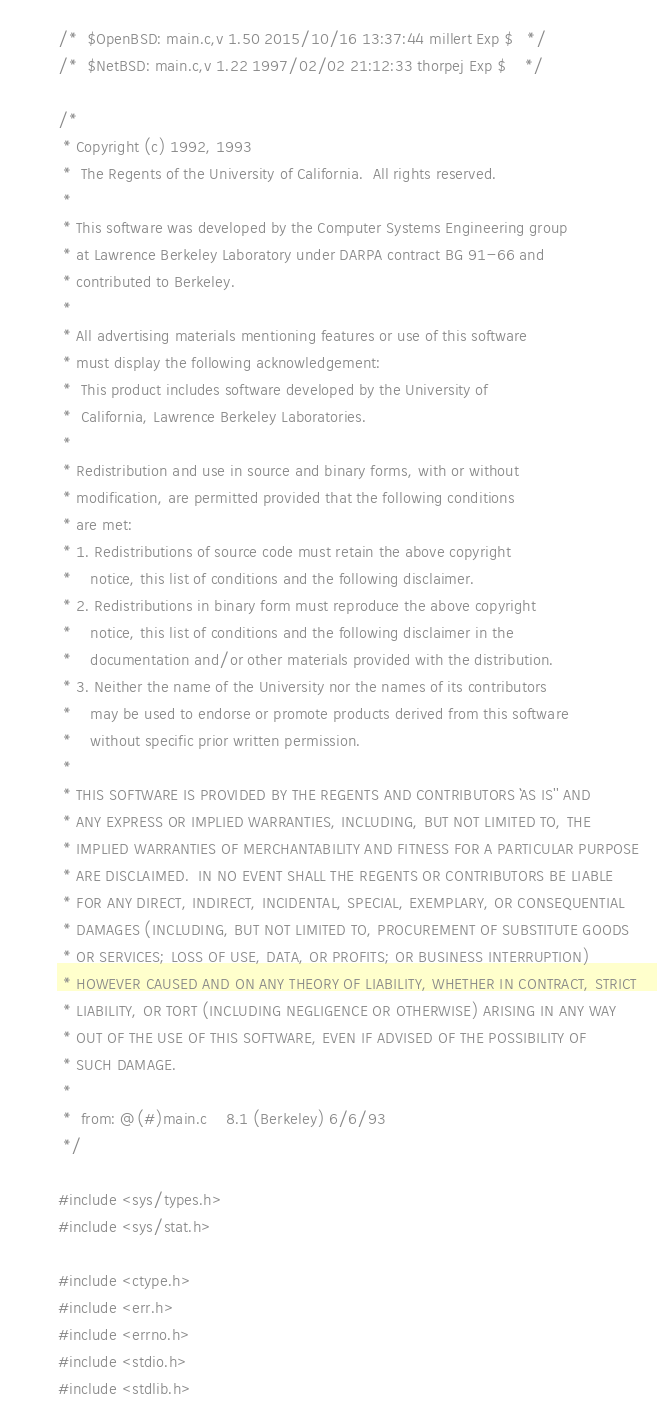<code> <loc_0><loc_0><loc_500><loc_500><_C_>/*	$OpenBSD: main.c,v 1.50 2015/10/16 13:37:44 millert Exp $	*/
/*	$NetBSD: main.c,v 1.22 1997/02/02 21:12:33 thorpej Exp $	*/

/*
 * Copyright (c) 1992, 1993
 *	The Regents of the University of California.  All rights reserved.
 *
 * This software was developed by the Computer Systems Engineering group
 * at Lawrence Berkeley Laboratory under DARPA contract BG 91-66 and
 * contributed to Berkeley.
 *
 * All advertising materials mentioning features or use of this software
 * must display the following acknowledgement:
 *	This product includes software developed by the University of
 *	California, Lawrence Berkeley Laboratories.
 *
 * Redistribution and use in source and binary forms, with or without
 * modification, are permitted provided that the following conditions
 * are met:
 * 1. Redistributions of source code must retain the above copyright
 *    notice, this list of conditions and the following disclaimer.
 * 2. Redistributions in binary form must reproduce the above copyright
 *    notice, this list of conditions and the following disclaimer in the
 *    documentation and/or other materials provided with the distribution.
 * 3. Neither the name of the University nor the names of its contributors
 *    may be used to endorse or promote products derived from this software
 *    without specific prior written permission.
 *
 * THIS SOFTWARE IS PROVIDED BY THE REGENTS AND CONTRIBUTORS ``AS IS'' AND
 * ANY EXPRESS OR IMPLIED WARRANTIES, INCLUDING, BUT NOT LIMITED TO, THE
 * IMPLIED WARRANTIES OF MERCHANTABILITY AND FITNESS FOR A PARTICULAR PURPOSE
 * ARE DISCLAIMED.  IN NO EVENT SHALL THE REGENTS OR CONTRIBUTORS BE LIABLE
 * FOR ANY DIRECT, INDIRECT, INCIDENTAL, SPECIAL, EXEMPLARY, OR CONSEQUENTIAL
 * DAMAGES (INCLUDING, BUT NOT LIMITED TO, PROCUREMENT OF SUBSTITUTE GOODS
 * OR SERVICES; LOSS OF USE, DATA, OR PROFITS; OR BUSINESS INTERRUPTION)
 * HOWEVER CAUSED AND ON ANY THEORY OF LIABILITY, WHETHER IN CONTRACT, STRICT
 * LIABILITY, OR TORT (INCLUDING NEGLIGENCE OR OTHERWISE) ARISING IN ANY WAY
 * OUT OF THE USE OF THIS SOFTWARE, EVEN IF ADVISED OF THE POSSIBILITY OF
 * SUCH DAMAGE.
 *
 *	from: @(#)main.c	8.1 (Berkeley) 6/6/93
 */

#include <sys/types.h>
#include <sys/stat.h>

#include <ctype.h>
#include <err.h>
#include <errno.h>
#include <stdio.h>
#include <stdlib.h></code> 